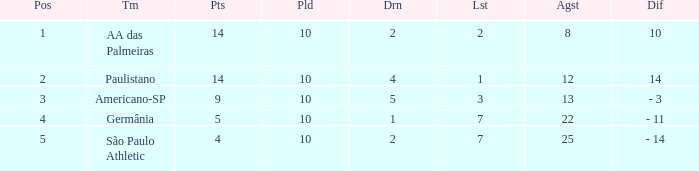What is the sum of Against when the lost is more than 7? None. 